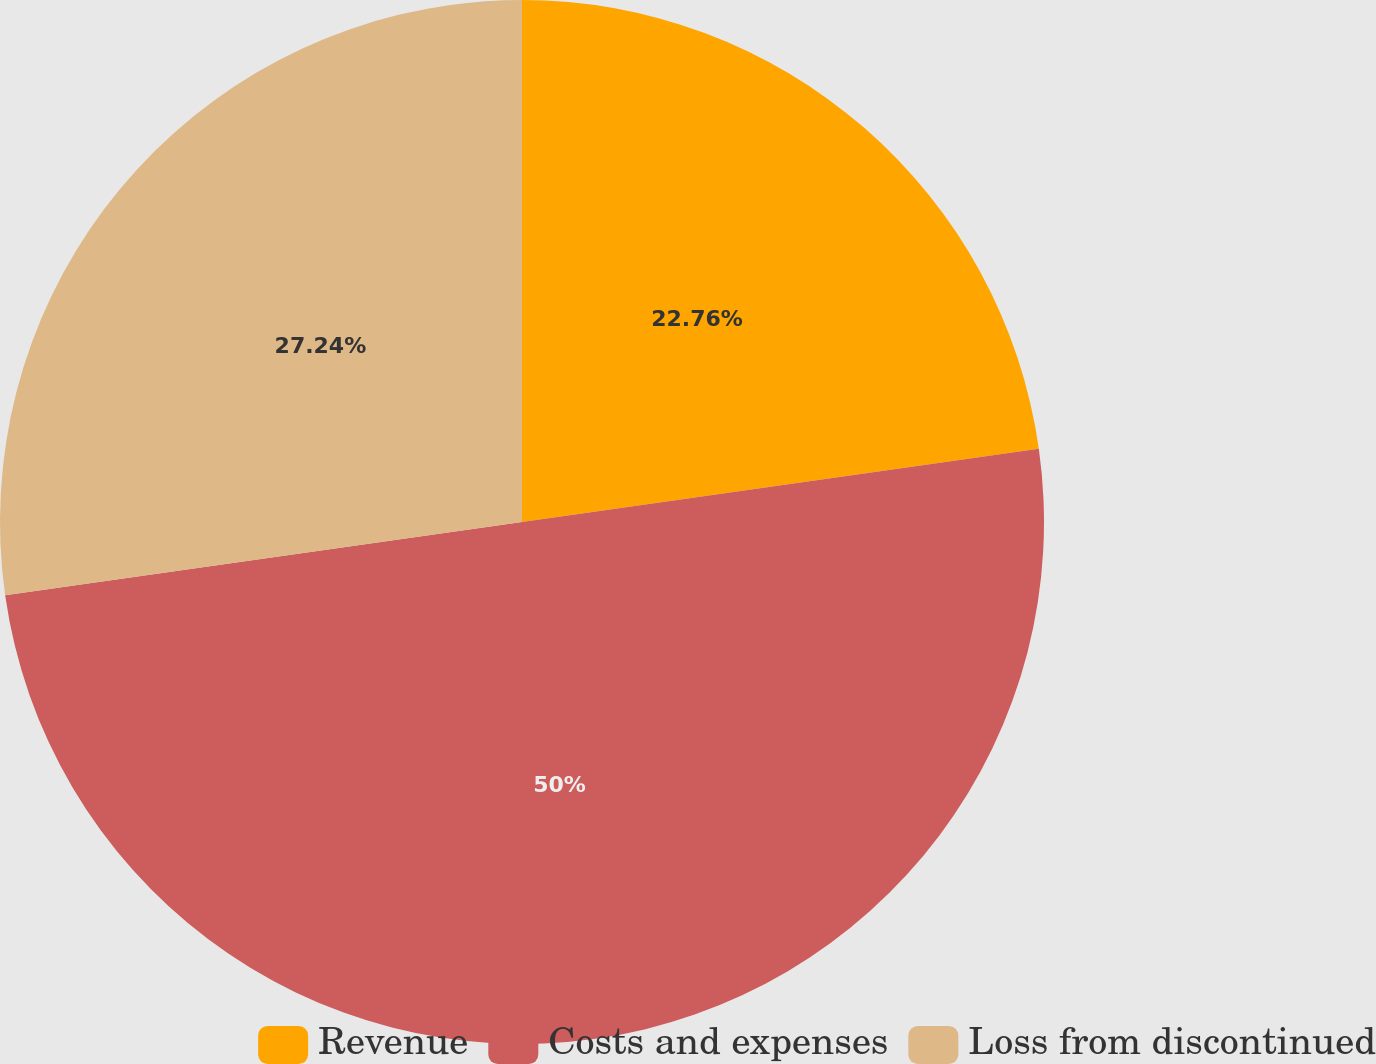Convert chart to OTSL. <chart><loc_0><loc_0><loc_500><loc_500><pie_chart><fcel>Revenue<fcel>Costs and expenses<fcel>Loss from discontinued<nl><fcel>22.76%<fcel>50.0%<fcel>27.24%<nl></chart> 